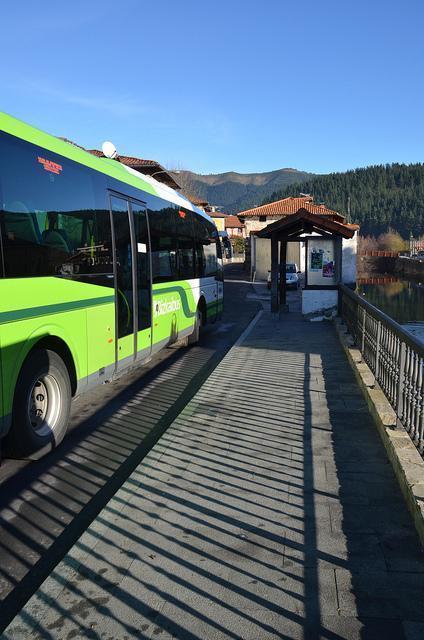How many dogs are sleeping in the image ?
Give a very brief answer. 0. 